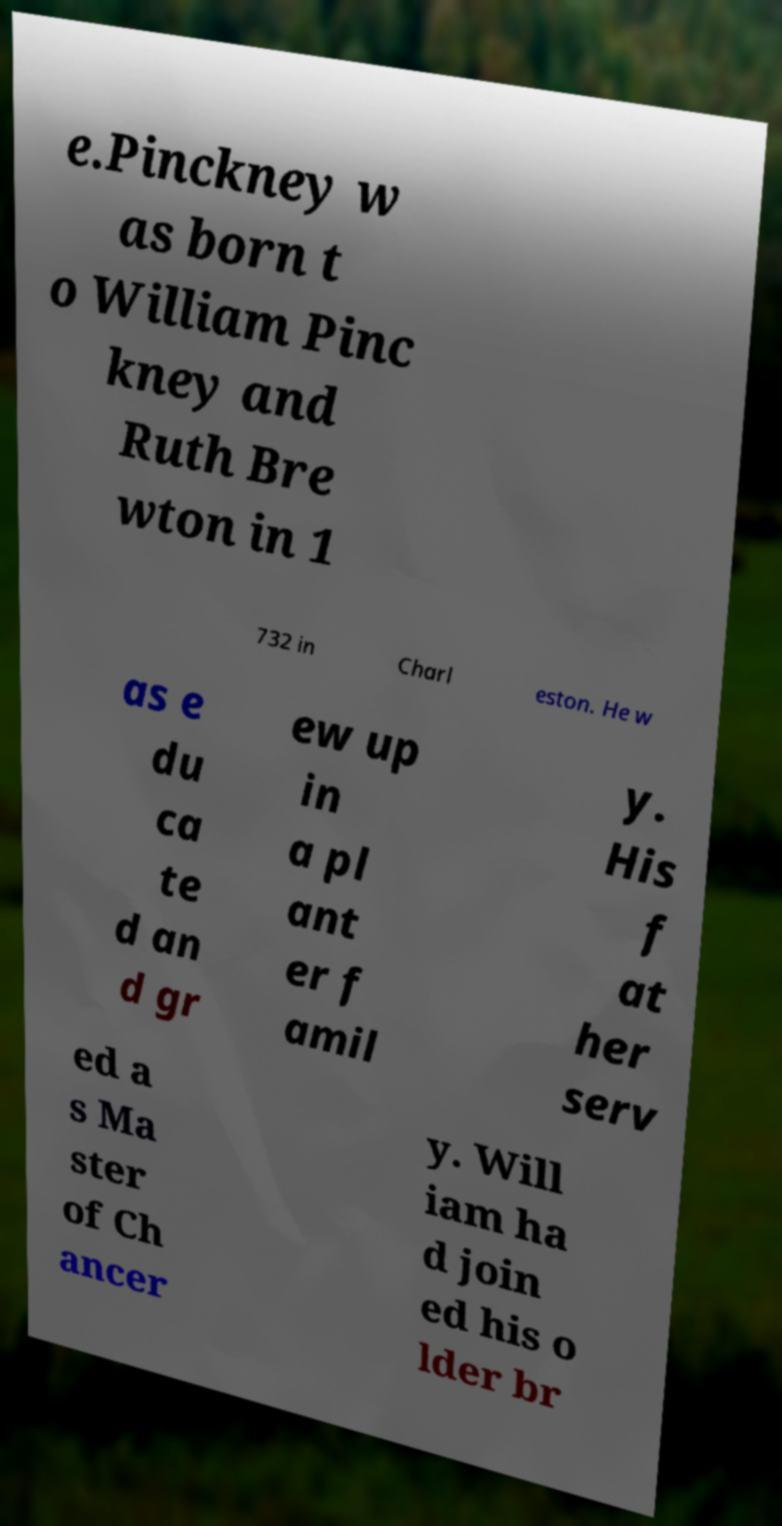Can you read and provide the text displayed in the image?This photo seems to have some interesting text. Can you extract and type it out for me? e.Pinckney w as born t o William Pinc kney and Ruth Bre wton in 1 732 in Charl eston. He w as e du ca te d an d gr ew up in a pl ant er f amil y. His f at her serv ed a s Ma ster of Ch ancer y. Will iam ha d join ed his o lder br 